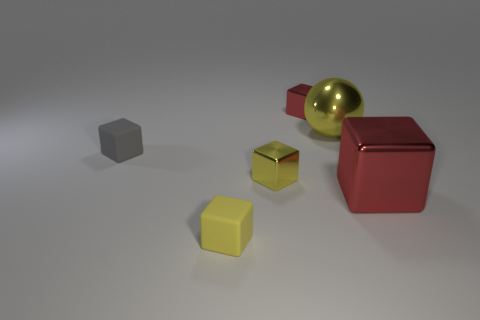What is the color of the large sphere?
Make the answer very short. Yellow. What number of other things are there of the same color as the large cube?
Give a very brief answer. 1. Are there any yellow metal cubes on the left side of the big red object?
Provide a succinct answer. Yes. There is a large object on the left side of the red metallic cube on the right side of the red cube behind the big red shiny thing; what is its color?
Ensure brevity in your answer.  Yellow. What number of cubes are in front of the small yellow shiny object and on the left side of the large red object?
Provide a succinct answer. 1. How many balls are yellow objects or small red objects?
Offer a terse response. 1. Is there a yellow metal sphere?
Offer a terse response. Yes. How many other things are made of the same material as the large red cube?
Offer a very short reply. 3. What is the material of the red cube that is the same size as the gray thing?
Your response must be concise. Metal. There is a small matte thing that is in front of the big red metallic object; is it the same shape as the tiny yellow metal object?
Ensure brevity in your answer.  Yes. 